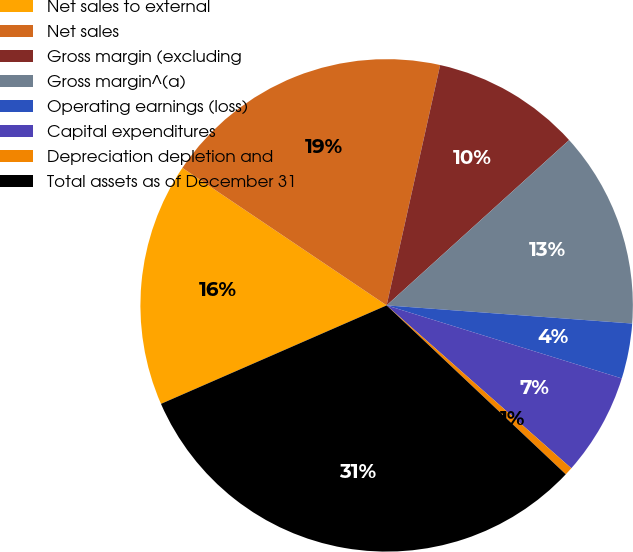Convert chart to OTSL. <chart><loc_0><loc_0><loc_500><loc_500><pie_chart><fcel>Net sales to external<fcel>Net sales<fcel>Gross margin (excluding<fcel>Gross margin^(a)<fcel>Operating earnings (loss)<fcel>Capital expenditures<fcel>Depreciation depletion and<fcel>Total assets as of December 31<nl><fcel>15.98%<fcel>19.06%<fcel>9.8%<fcel>12.89%<fcel>3.62%<fcel>6.71%<fcel>0.53%<fcel>31.42%<nl></chart> 